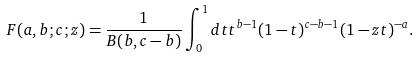<formula> <loc_0><loc_0><loc_500><loc_500>F ( a , b ; c ; z ) = \frac { 1 } { B ( b , c - b ) } \int _ { 0 } ^ { 1 } d t t ^ { b - 1 } ( 1 - t ) ^ { c - b - 1 } ( 1 - z t ) ^ { - a } .</formula> 